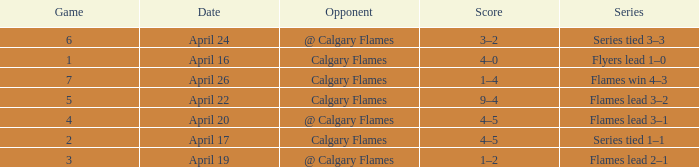Which Date has a Score of 4–5, and a Game smaller than 4? April 17. 